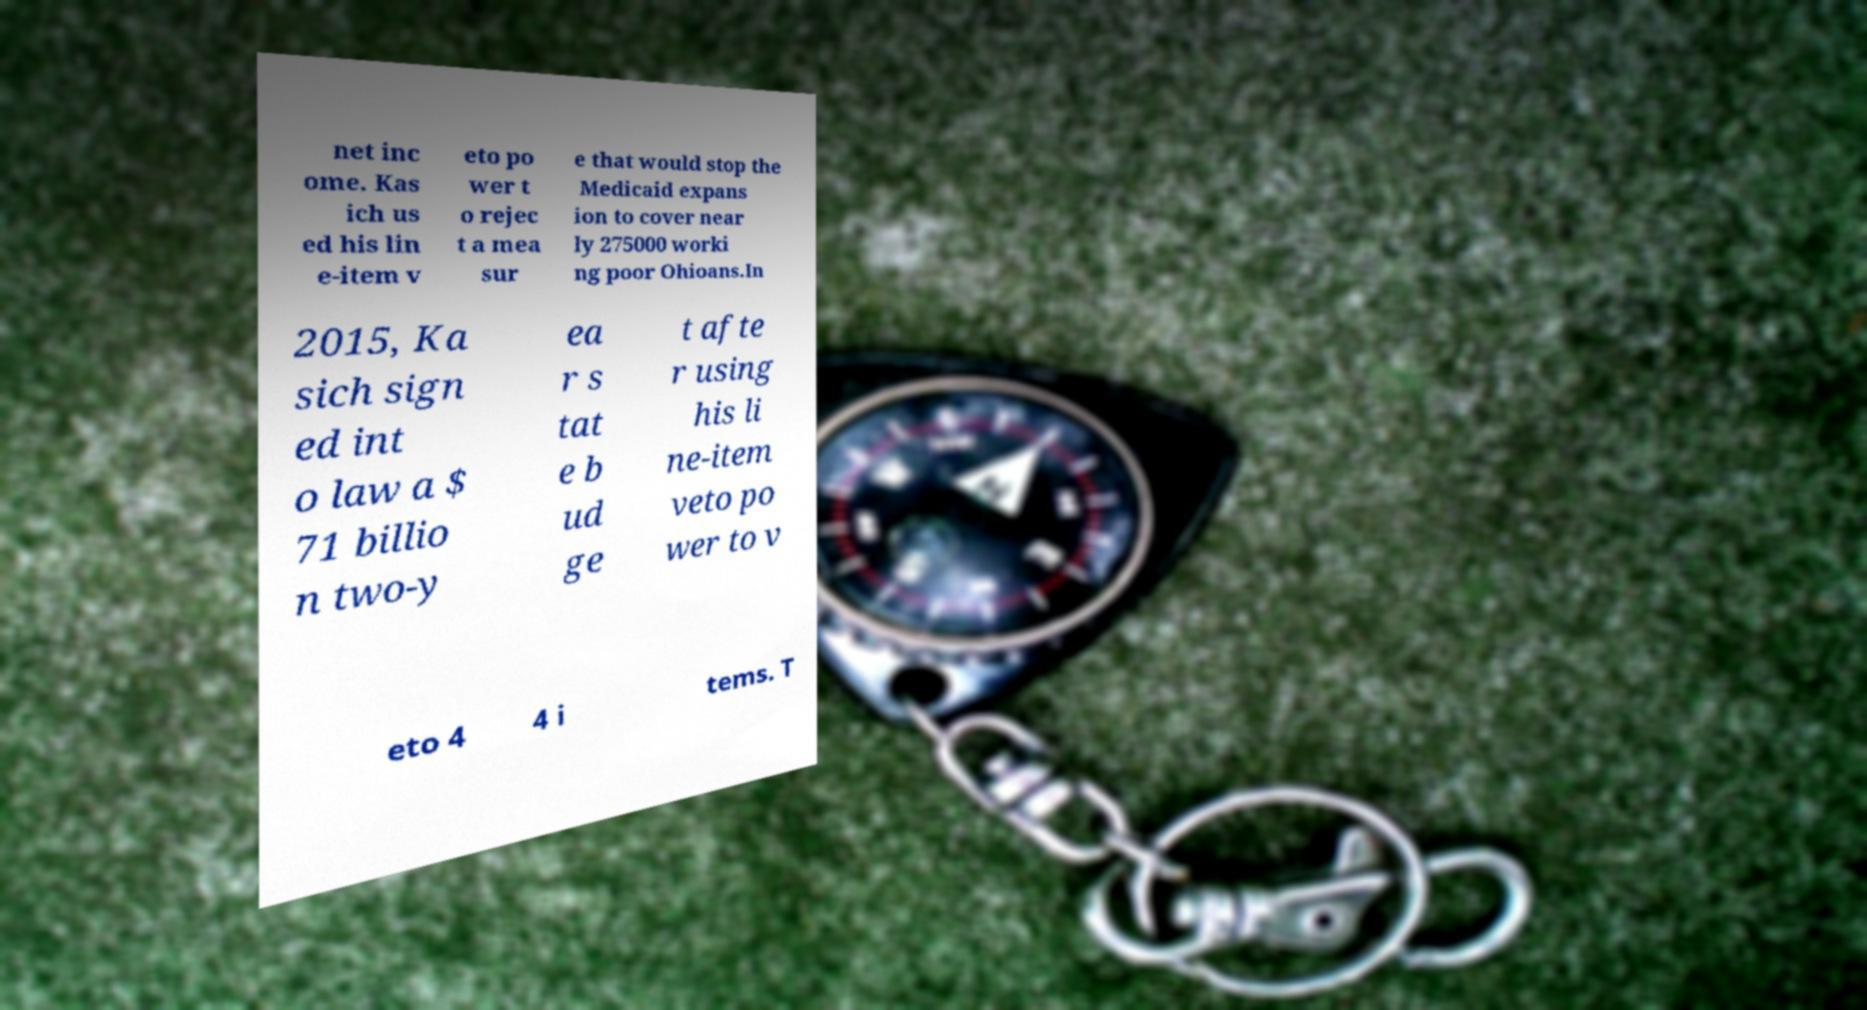Can you accurately transcribe the text from the provided image for me? net inc ome. Kas ich us ed his lin e-item v eto po wer t o rejec t a mea sur e that would stop the Medicaid expans ion to cover near ly 275000 worki ng poor Ohioans.In 2015, Ka sich sign ed int o law a $ 71 billio n two-y ea r s tat e b ud ge t afte r using his li ne-item veto po wer to v eto 4 4 i tems. T 